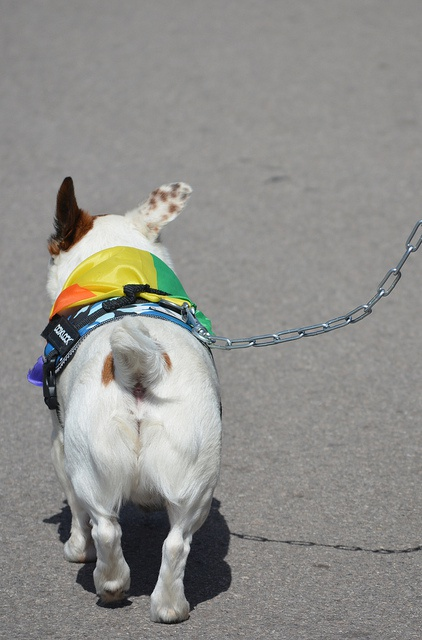Describe the objects in this image and their specific colors. I can see a dog in gray, lightgray, darkgray, and black tones in this image. 